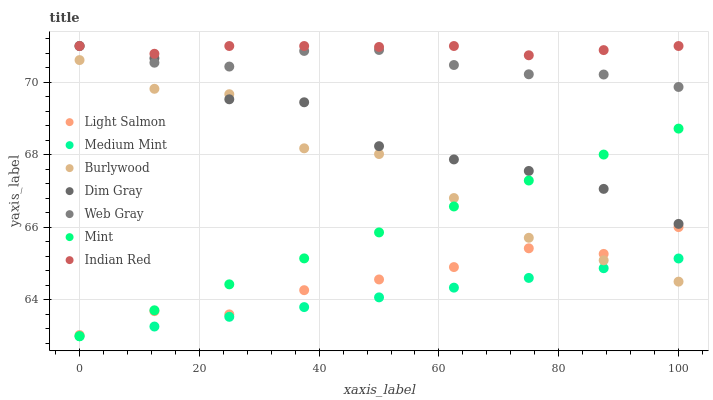Does Medium Mint have the minimum area under the curve?
Answer yes or no. Yes. Does Indian Red have the maximum area under the curve?
Answer yes or no. Yes. Does Light Salmon have the minimum area under the curve?
Answer yes or no. No. Does Light Salmon have the maximum area under the curve?
Answer yes or no. No. Is Medium Mint the smoothest?
Answer yes or no. Yes. Is Burlywood the roughest?
Answer yes or no. Yes. Is Light Salmon the smoothest?
Answer yes or no. No. Is Light Salmon the roughest?
Answer yes or no. No. Does Medium Mint have the lowest value?
Answer yes or no. Yes. Does Light Salmon have the lowest value?
Answer yes or no. No. Does Indian Red have the highest value?
Answer yes or no. Yes. Does Light Salmon have the highest value?
Answer yes or no. No. Is Light Salmon less than Dim Gray?
Answer yes or no. Yes. Is Web Gray greater than Medium Mint?
Answer yes or no. Yes. Does Burlywood intersect Medium Mint?
Answer yes or no. Yes. Is Burlywood less than Medium Mint?
Answer yes or no. No. Is Burlywood greater than Medium Mint?
Answer yes or no. No. Does Light Salmon intersect Dim Gray?
Answer yes or no. No. 